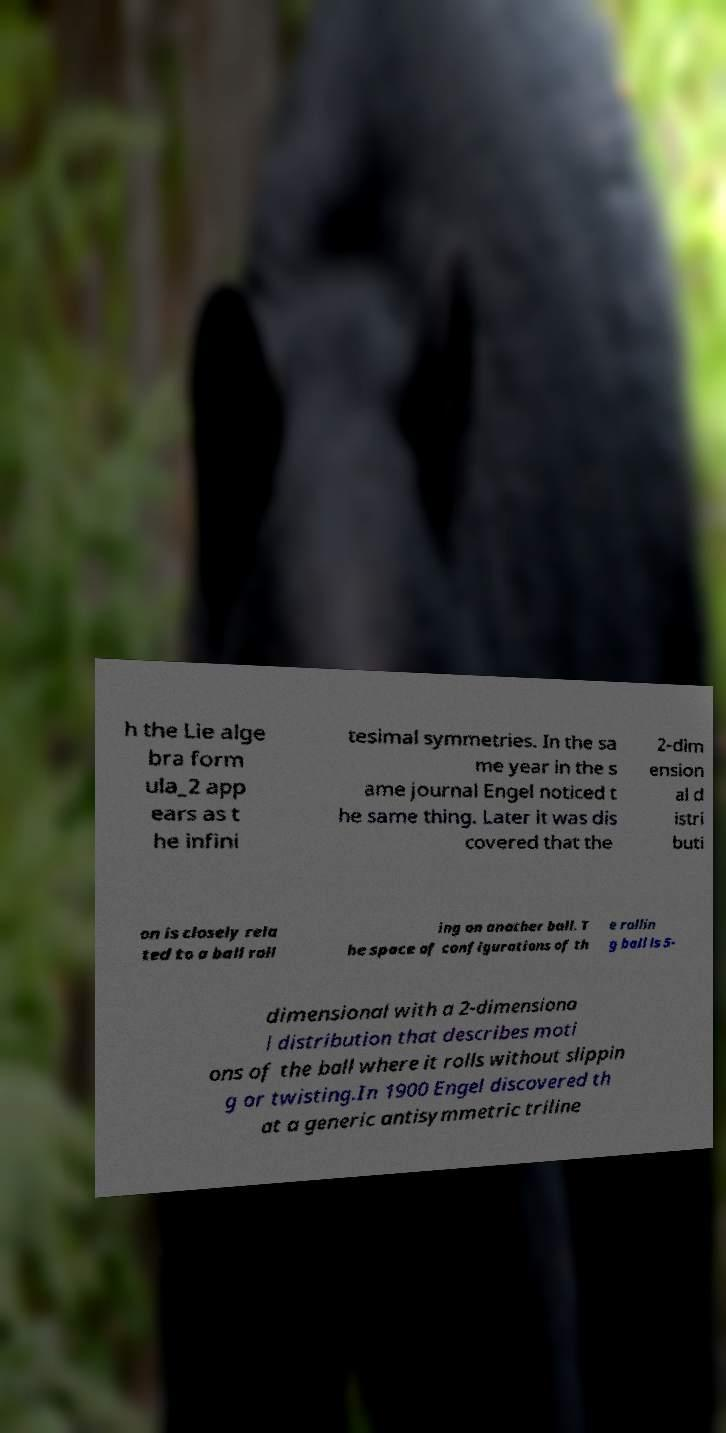Could you assist in decoding the text presented in this image and type it out clearly? h the Lie alge bra form ula_2 app ears as t he infini tesimal symmetries. In the sa me year in the s ame journal Engel noticed t he same thing. Later it was dis covered that the 2-dim ension al d istri buti on is closely rela ted to a ball roll ing on another ball. T he space of configurations of th e rollin g ball is 5- dimensional with a 2-dimensiona l distribution that describes moti ons of the ball where it rolls without slippin g or twisting.In 1900 Engel discovered th at a generic antisymmetric triline 